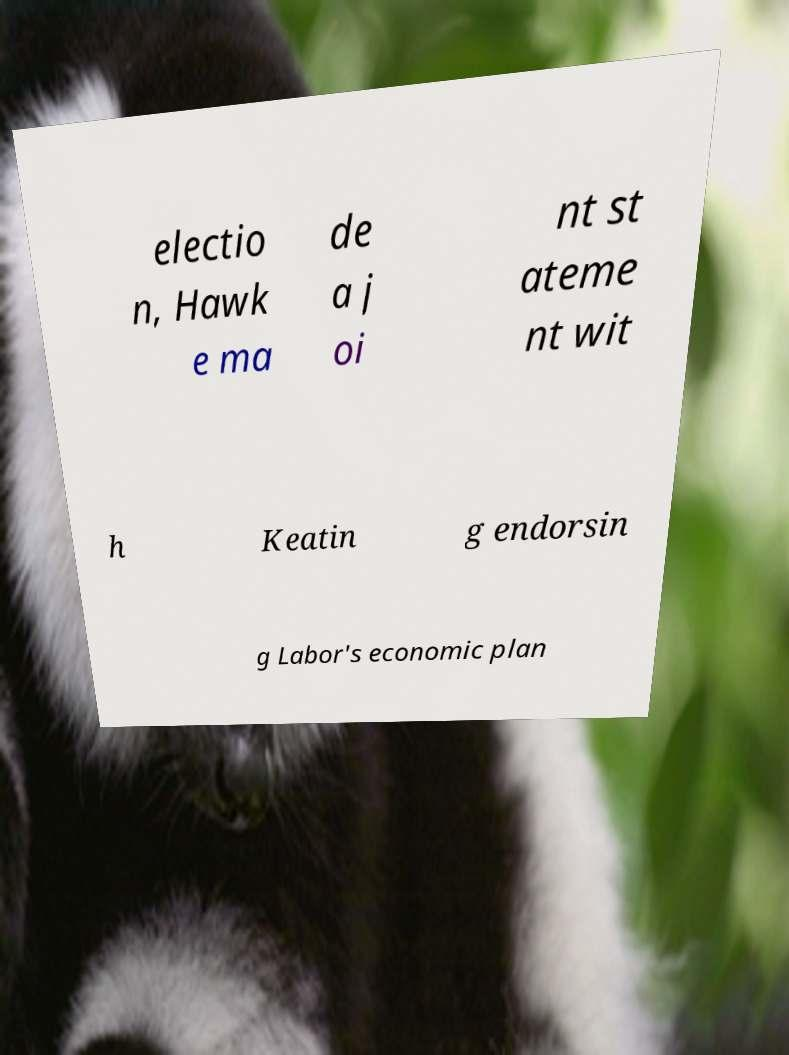I need the written content from this picture converted into text. Can you do that? electio n, Hawk e ma de a j oi nt st ateme nt wit h Keatin g endorsin g Labor's economic plan 